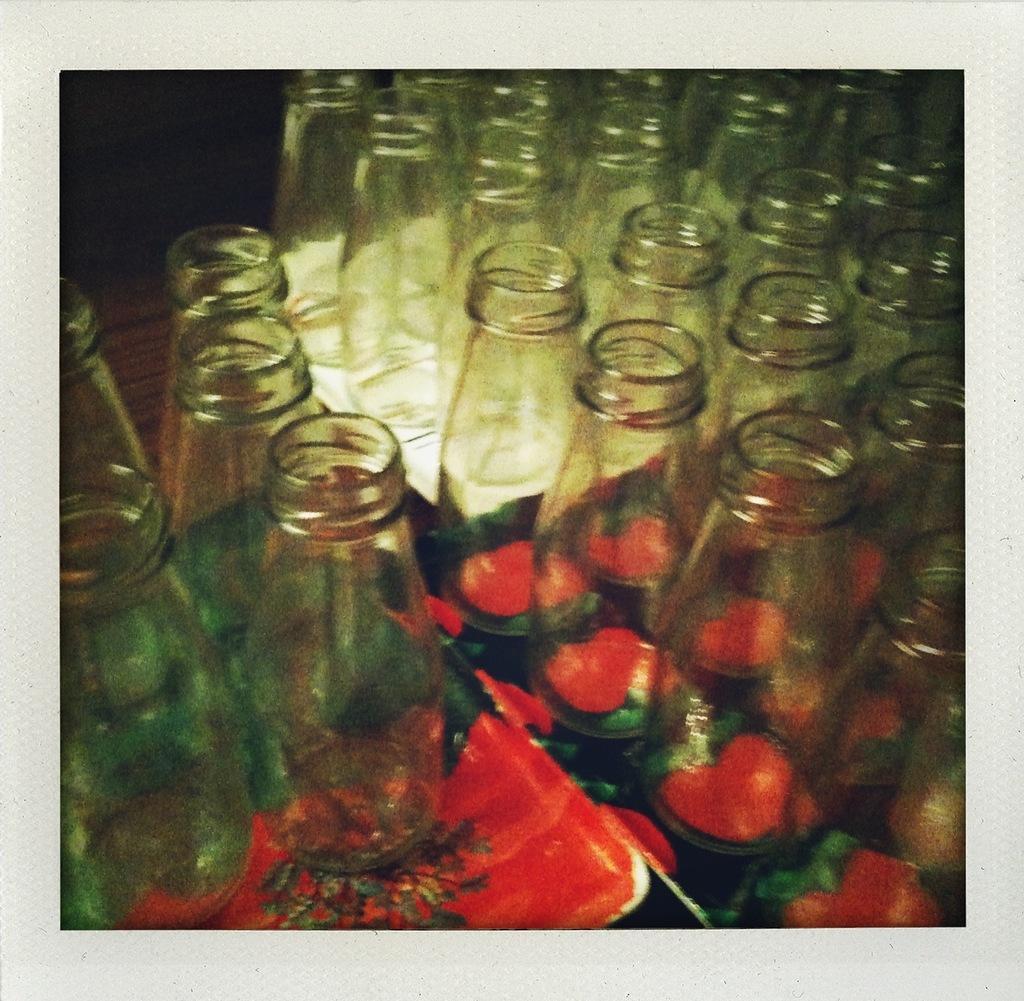How would you summarize this image in a sentence or two? This image consists of glass bottles on the left side. They are placed on a plate. There is a mirror in the middle. There is the reflection of glass bottles on the right side. 